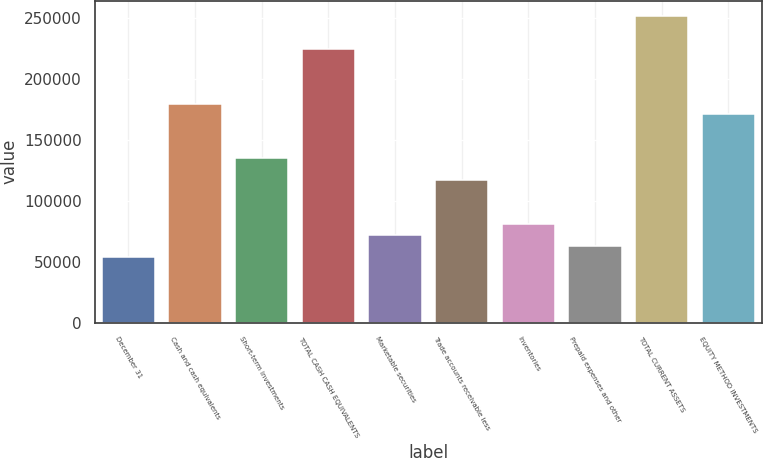<chart> <loc_0><loc_0><loc_500><loc_500><bar_chart><fcel>December 31<fcel>Cash and cash equivalents<fcel>Short-term investments<fcel>TOTAL CASH CASH EQUIVALENTS<fcel>Marketable securities<fcel>Trade accounts receivable less<fcel>Inventories<fcel>Prepaid expenses and other<fcel>TOTAL CURRENT ASSETS<fcel>EQUITY METHOD INVESTMENTS<nl><fcel>54139.8<fcel>179843<fcel>134949<fcel>224737<fcel>72097.4<fcel>116991<fcel>81076.2<fcel>63118.6<fcel>251673<fcel>170864<nl></chart> 